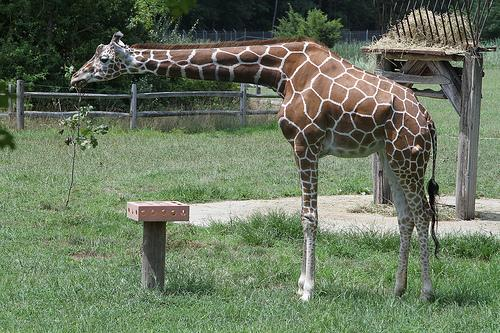State the position of the hay in relation to the giraffe. The hay is behind the giraffe, placed on wooden posts within the enclosed area where the giraffe is standing. Is there any object in the image that is neither a part of the giraffe nor the surrounding area? Yes, there is a wooden feeder placed near the hay, which is not a part of the giraffe or the surrounding area. What type of task would require identifying the distinguishing features of the giraffe? A referential expression grounding task would require identifying the distinguishing features of the giraffe. What is the aesthetic difference between the neck of the giraffe and the grass in the image? The neck of the giraffe is long, with mane hair on it and comes in a single color, while the grass is short, green, and appears in multiple patches. Can you identify any food sources for the giraffe within the image? There is tan hay in a holder, held by a metal grid, and a small tree that the giraffe appears to be eating, as potential food sources. Describe the surface the giraffe is standing on in the image. The giraffe is standing on a grassy surface with tufts of green grass and patches of grass throughout the image. What type of fencing surrounds the area where the giraffe is standing? A wooden post fence surrounds the area where the giraffe is standing. For a product advertisement task, how could you promote a toy giraffe based on the image? Introducing our realistic toy giraffe, featuring a long neck, mane hair, four legs, and distinctive facial features! Let your child explore the wonder of nature with this lifelike replica, complete with brown spots and the appearance of standing on a grassy surface! Describe the appearance of the giraffe in the image. The giraffe has a long neck with mane hair, brown spots on its body, four legs, a tail, and distinctive features such as eyes, nose, and mouth. 